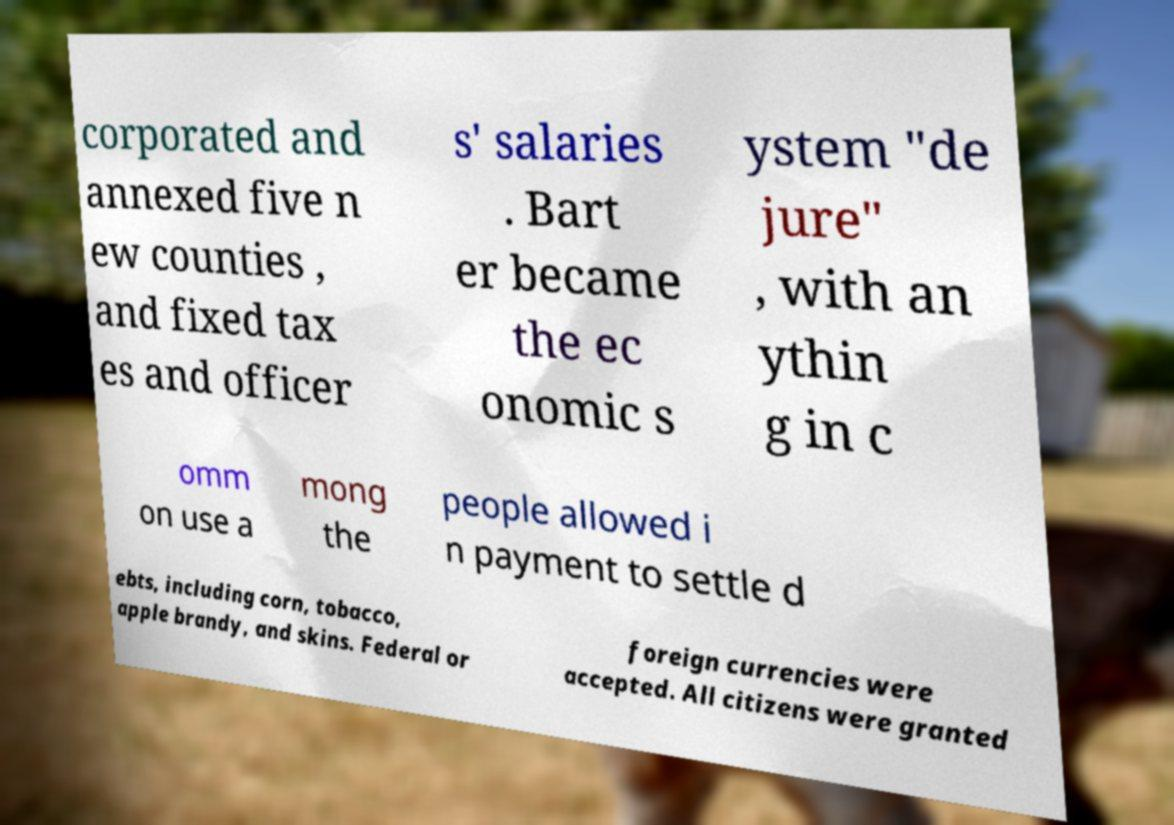There's text embedded in this image that I need extracted. Can you transcribe it verbatim? corporated and annexed five n ew counties , and fixed tax es and officer s' salaries . Bart er became the ec onomic s ystem "de jure" , with an ythin g in c omm on use a mong the people allowed i n payment to settle d ebts, including corn, tobacco, apple brandy, and skins. Federal or foreign currencies were accepted. All citizens were granted 